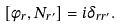<formula> <loc_0><loc_0><loc_500><loc_500>[ \phi _ { r } , N _ { r ^ { \prime } } ] = i \delta _ { r r ^ { \prime } } .</formula> 